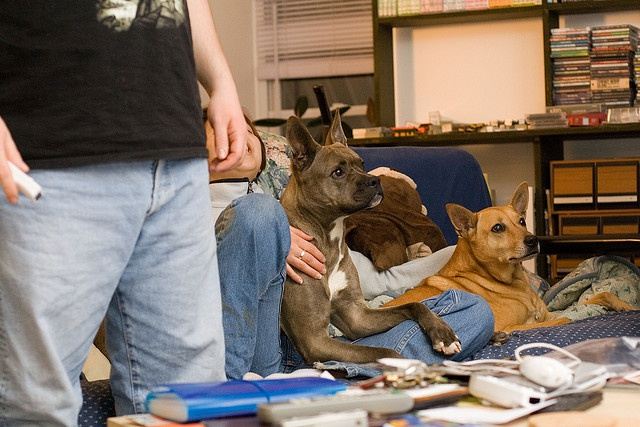Describe the objects in this image and their specific colors. I can see people in black, darkgray, and lightgray tones, dog in black, maroon, and gray tones, people in black, gray, and blue tones, dog in black, olive, tan, and maroon tones, and couch in black and gray tones in this image. 